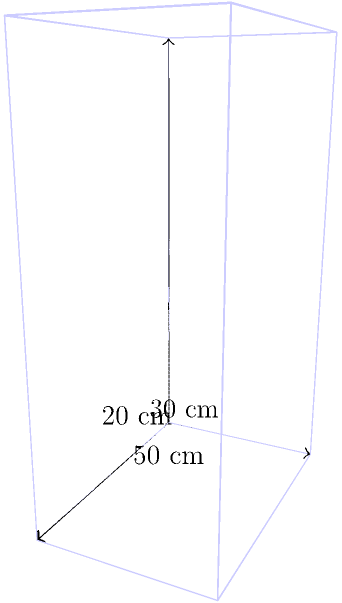As a travel influencer, you're always on the lookout for the perfect carry-on suitcase. You've found a sleek model with dimensions 30 cm × 20 cm × 50 cm. What is the volume of this suitcase in liters, rounded to the nearest whole number? To calculate the volume of the suitcase, we need to follow these steps:

1) The volume of a rectangular prism (like a suitcase) is given by the formula:
   $$V = l \times w \times h$$
   where $V$ is volume, $l$ is length, $w$ is width, and $h$ is height.

2) We have:
   $l = 30$ cm
   $w = 20$ cm
   $h = 50$ cm

3) Substituting these values into the formula:
   $$V = 30 \times 20 \times 50 = 30,000 \text{ cm}^3$$

4) To convert cubic centimeters to liters, we use the conversion factor:
   $$1 \text{ L} = 1000 \text{ cm}^3$$

5) So, we divide our result by 1000:
   $$30,000 \text{ cm}^3 \div 1000 = 30 \text{ L}$$

6) The question asks for the answer rounded to the nearest whole number, but 30 is already a whole number.

Therefore, the volume of the suitcase is 30 liters.
Answer: 30 L 